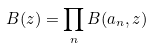<formula> <loc_0><loc_0><loc_500><loc_500>B ( z ) = \prod _ { n } B ( a _ { n } , z )</formula> 